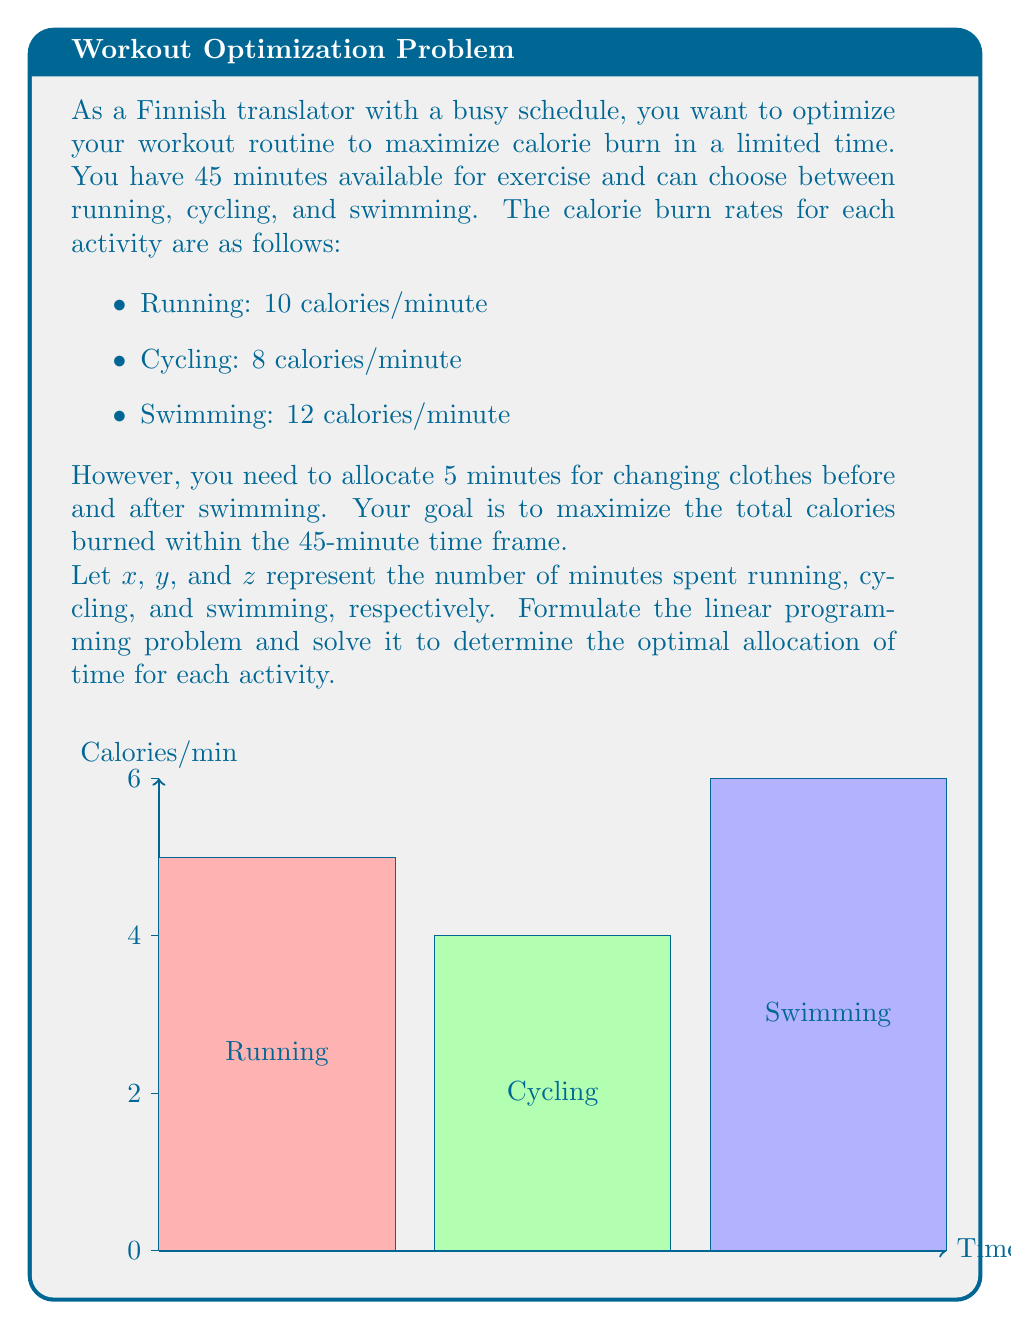Teach me how to tackle this problem. Let's solve this problem step by step:

1) First, we need to set up the objective function to maximize calories burned:
   $$\text{Maximize } 10x + 8y + 12z$$

2) Now, we need to consider the constraints:

   a) Total time constraint: $x + y + z + 5 = 45$ (including 5 minutes for changing clothes for swimming)
   b) Non-negativity constraints: $x \geq 0, y \geq 0, z \geq 0$

3) Simplify the time constraint: $x + y + z = 40$

4) We can solve this using the simplex method or graphically. Given the simplicity of the problem, let's use logical reasoning:

   - Swimming burns the most calories per minute (12 cal/min)
   - Running is second (10 cal/min)
   - Cycling burns the least (8 cal/min)

5) To maximize calorie burn, we should allocate as much time as possible to swimming, then running, and lastly cycling.

6) Allocate maximum time to swimming:
   $z = 40$ (maximum available time)

7) Calculate total calories burned:
   $12 * 40 = 480$ calories

Therefore, the optimal solution is to spend all 40 minutes swimming (plus 5 minutes for changing), which will burn 480 calories.
Answer: Swim for 40 minutes 